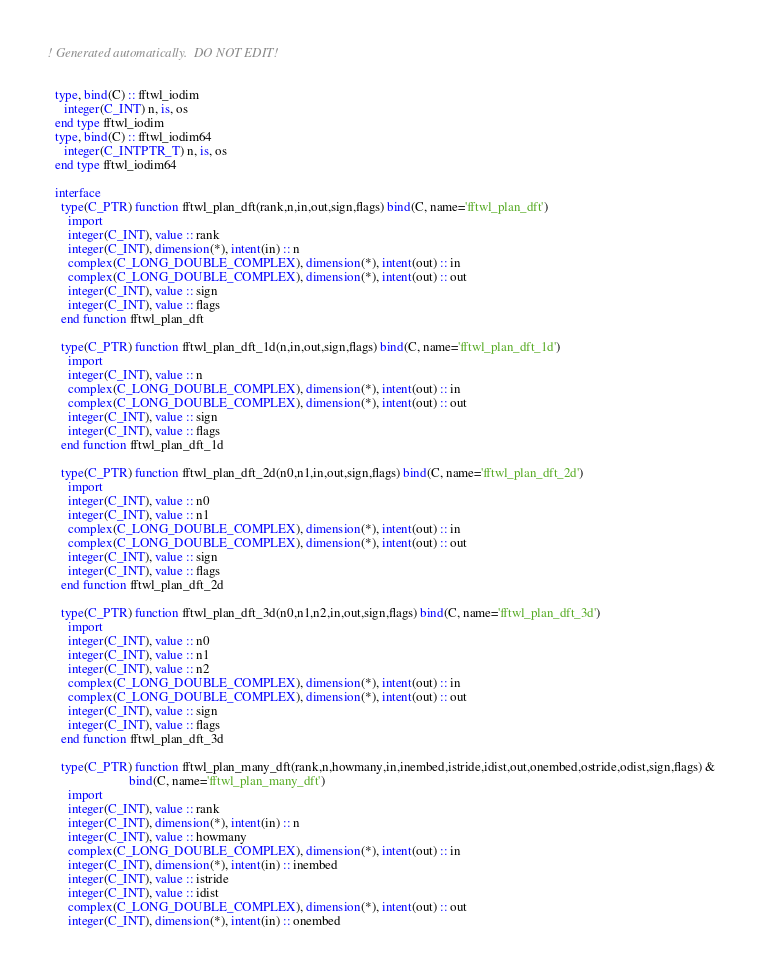Convert code to text. <code><loc_0><loc_0><loc_500><loc_500><_FORTRAN_>! Generated automatically.  DO NOT EDIT!


  type, bind(C) :: fftwl_iodim
     integer(C_INT) n, is, os
  end type fftwl_iodim
  type, bind(C) :: fftwl_iodim64
     integer(C_INTPTR_T) n, is, os
  end type fftwl_iodim64

  interface
    type(C_PTR) function fftwl_plan_dft(rank,n,in,out,sign,flags) bind(C, name='fftwl_plan_dft')
      import
      integer(C_INT), value :: rank
      integer(C_INT), dimension(*), intent(in) :: n
      complex(C_LONG_DOUBLE_COMPLEX), dimension(*), intent(out) :: in
      complex(C_LONG_DOUBLE_COMPLEX), dimension(*), intent(out) :: out
      integer(C_INT), value :: sign
      integer(C_INT), value :: flags
    end function fftwl_plan_dft
    
    type(C_PTR) function fftwl_plan_dft_1d(n,in,out,sign,flags) bind(C, name='fftwl_plan_dft_1d')
      import
      integer(C_INT), value :: n
      complex(C_LONG_DOUBLE_COMPLEX), dimension(*), intent(out) :: in
      complex(C_LONG_DOUBLE_COMPLEX), dimension(*), intent(out) :: out
      integer(C_INT), value :: sign
      integer(C_INT), value :: flags
    end function fftwl_plan_dft_1d
    
    type(C_PTR) function fftwl_plan_dft_2d(n0,n1,in,out,sign,flags) bind(C, name='fftwl_plan_dft_2d')
      import
      integer(C_INT), value :: n0
      integer(C_INT), value :: n1
      complex(C_LONG_DOUBLE_COMPLEX), dimension(*), intent(out) :: in
      complex(C_LONG_DOUBLE_COMPLEX), dimension(*), intent(out) :: out
      integer(C_INT), value :: sign
      integer(C_INT), value :: flags
    end function fftwl_plan_dft_2d
    
    type(C_PTR) function fftwl_plan_dft_3d(n0,n1,n2,in,out,sign,flags) bind(C, name='fftwl_plan_dft_3d')
      import
      integer(C_INT), value :: n0
      integer(C_INT), value :: n1
      integer(C_INT), value :: n2
      complex(C_LONG_DOUBLE_COMPLEX), dimension(*), intent(out) :: in
      complex(C_LONG_DOUBLE_COMPLEX), dimension(*), intent(out) :: out
      integer(C_INT), value :: sign
      integer(C_INT), value :: flags
    end function fftwl_plan_dft_3d
    
    type(C_PTR) function fftwl_plan_many_dft(rank,n,howmany,in,inembed,istride,idist,out,onembed,ostride,odist,sign,flags) &
                         bind(C, name='fftwl_plan_many_dft')
      import
      integer(C_INT), value :: rank
      integer(C_INT), dimension(*), intent(in) :: n
      integer(C_INT), value :: howmany
      complex(C_LONG_DOUBLE_COMPLEX), dimension(*), intent(out) :: in
      integer(C_INT), dimension(*), intent(in) :: inembed
      integer(C_INT), value :: istride
      integer(C_INT), value :: idist
      complex(C_LONG_DOUBLE_COMPLEX), dimension(*), intent(out) :: out
      integer(C_INT), dimension(*), intent(in) :: onembed</code> 